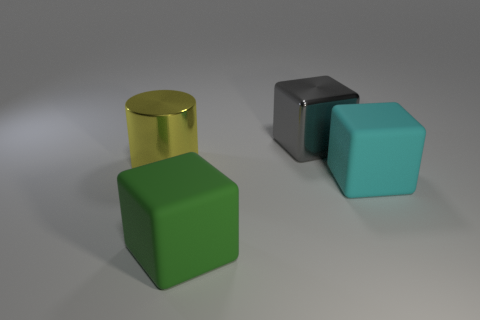Add 4 cyan matte blocks. How many objects exist? 8 Subtract all blocks. How many objects are left? 1 Add 3 large cylinders. How many large cylinders exist? 4 Subtract 0 purple cylinders. How many objects are left? 4 Subtract all big rubber blocks. Subtract all big green matte blocks. How many objects are left? 1 Add 4 gray things. How many gray things are left? 5 